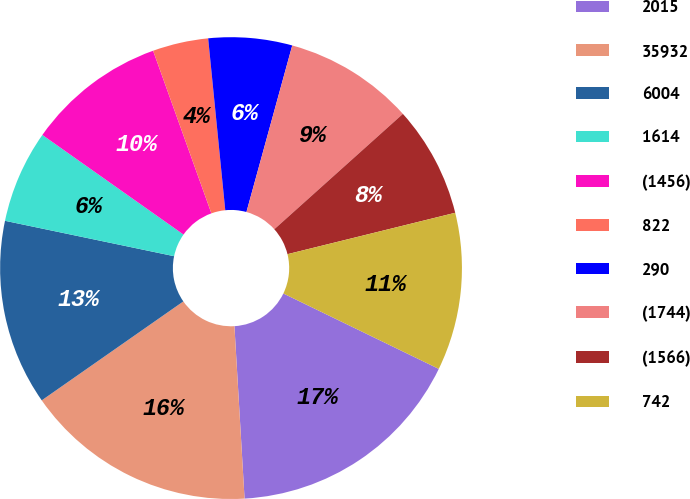Convert chart to OTSL. <chart><loc_0><loc_0><loc_500><loc_500><pie_chart><fcel>2015<fcel>35932<fcel>6004<fcel>1614<fcel>(1456)<fcel>822<fcel>290<fcel>(1744)<fcel>(1566)<fcel>742<nl><fcel>16.88%<fcel>16.23%<fcel>12.99%<fcel>6.5%<fcel>9.74%<fcel>3.9%<fcel>5.85%<fcel>9.09%<fcel>7.79%<fcel>11.04%<nl></chart> 